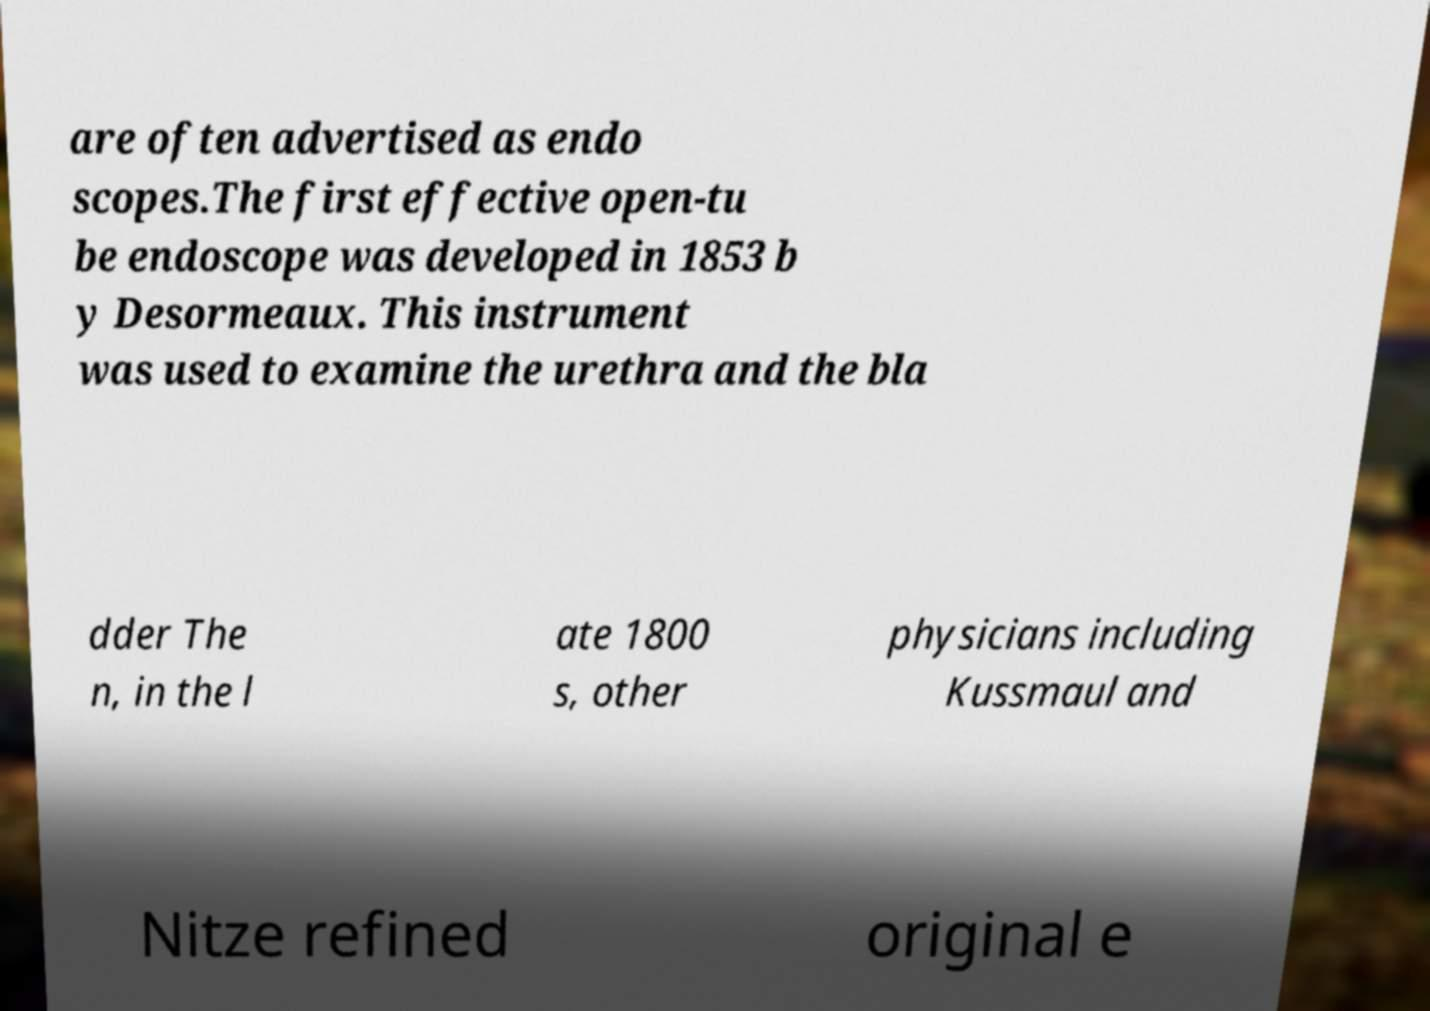Can you accurately transcribe the text from the provided image for me? are often advertised as endo scopes.The first effective open-tu be endoscope was developed in 1853 b y Desormeaux. This instrument was used to examine the urethra and the bla dder The n, in the l ate 1800 s, other physicians including Kussmaul and Nitze refined original e 